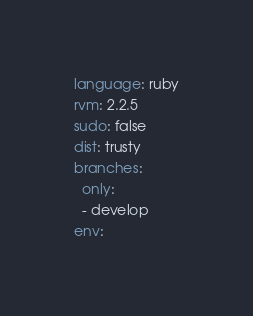<code> <loc_0><loc_0><loc_500><loc_500><_YAML_>language: ruby
rvm: 2.2.5
sudo: false
dist: trusty
branches:
  only:
  - develop
env:</code> 